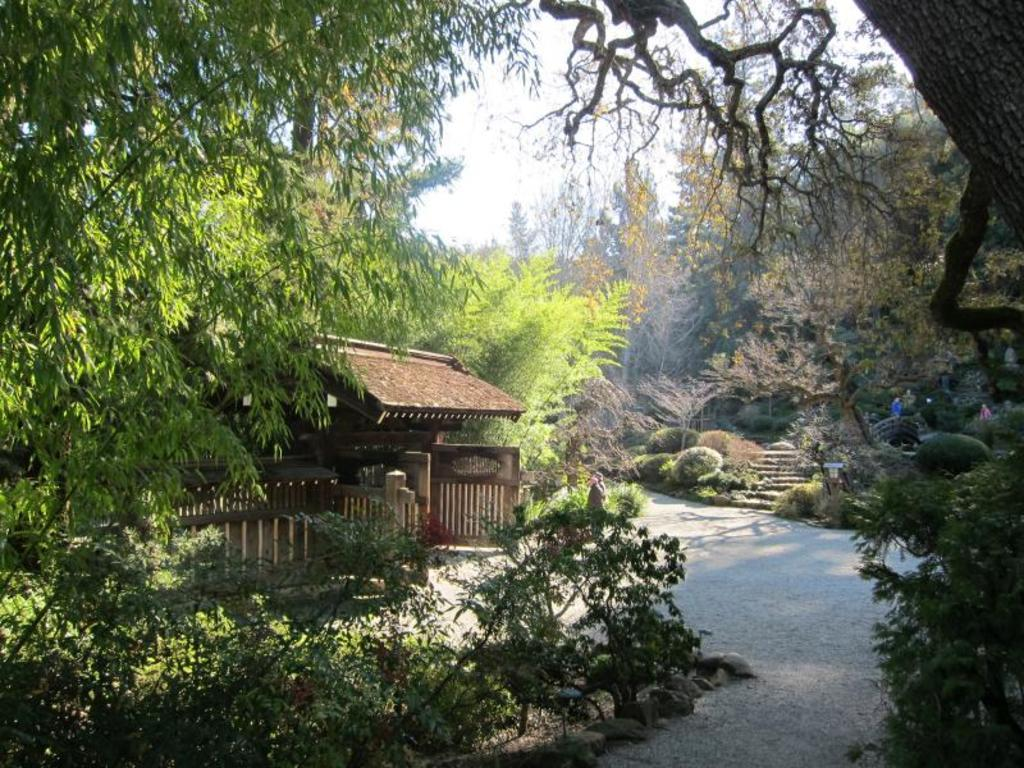What type of structure is present in the image? There is a building in the image. What type of pathway is present in the image? There is a walkway bridge in the image. What type of barrier is present in the image? There are wooden fences in the image. What type of vegetation is present in the image? There are bushes, plants, and trees in the image. What is visible in the background of the image? The sky is visible in the image. Where is the fire located in the image? There is no fire present in the image. What type of curve can be seen in the image? There is no curve present in the image. What type of building is present in the image? The building in the image is not specified as a library or any other specific type of building. 